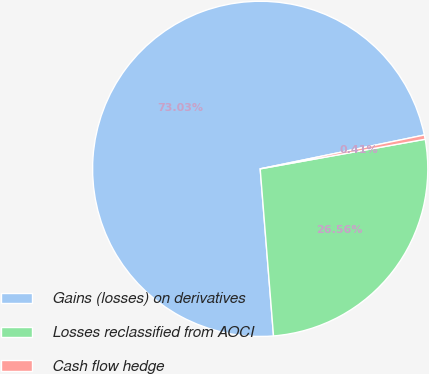<chart> <loc_0><loc_0><loc_500><loc_500><pie_chart><fcel>Gains (losses) on derivatives<fcel>Losses reclassified from AOCI<fcel>Cash flow hedge<nl><fcel>73.03%<fcel>26.56%<fcel>0.41%<nl></chart> 